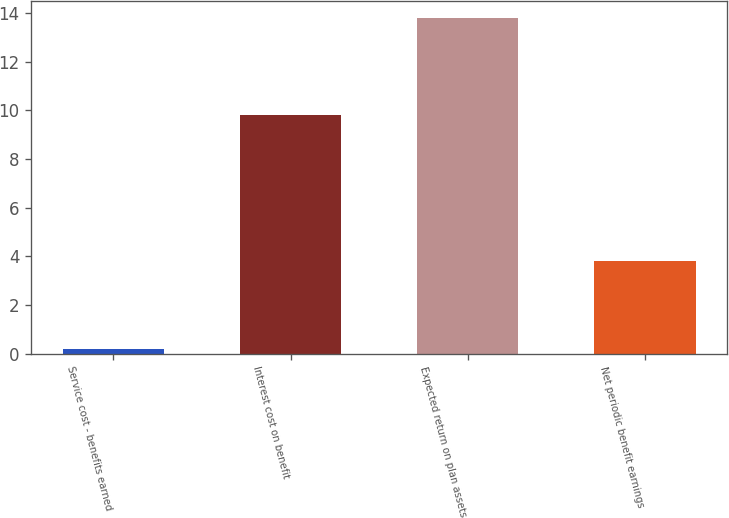Convert chart to OTSL. <chart><loc_0><loc_0><loc_500><loc_500><bar_chart><fcel>Service cost - benefits earned<fcel>Interest cost on benefit<fcel>Expected return on plan assets<fcel>Net periodic benefit earnings<nl><fcel>0.2<fcel>9.8<fcel>13.8<fcel>3.8<nl></chart> 